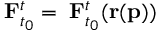<formula> <loc_0><loc_0><loc_500><loc_500>\nabla F _ { t _ { 0 } } ^ { t } = \nabla F _ { t _ { 0 } } ^ { t } ( r ( p ) )</formula> 